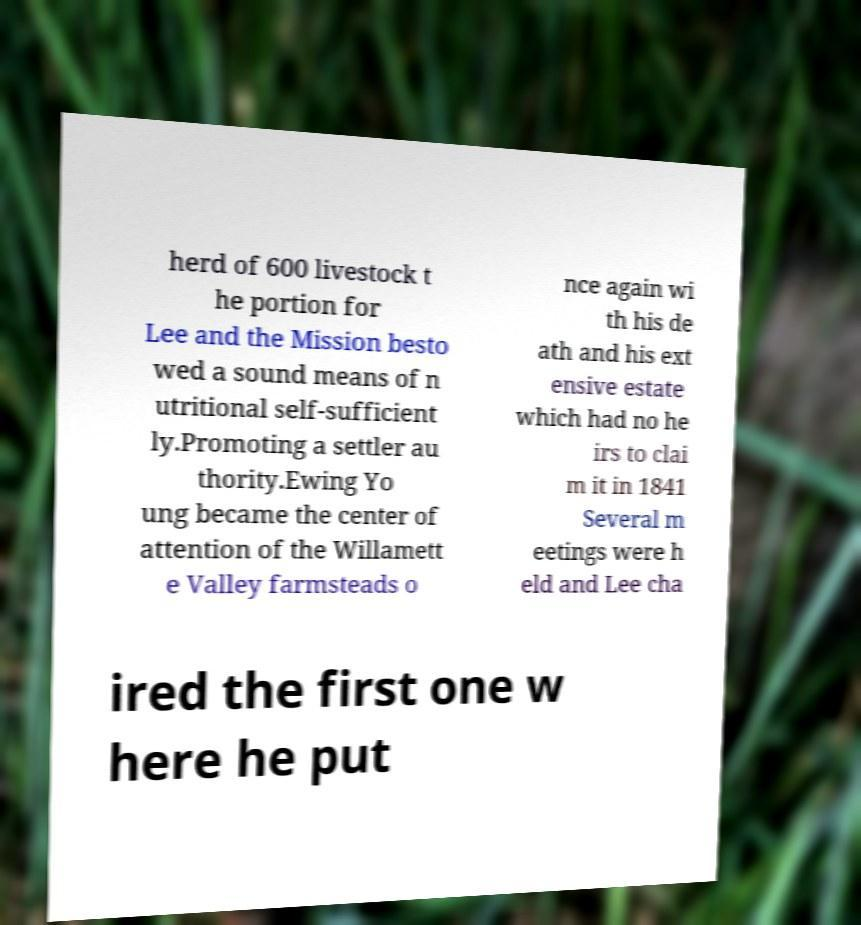Could you assist in decoding the text presented in this image and type it out clearly? herd of 600 livestock t he portion for Lee and the Mission besto wed a sound means of n utritional self-sufficient ly.Promoting a settler au thority.Ewing Yo ung became the center of attention of the Willamett e Valley farmsteads o nce again wi th his de ath and his ext ensive estate which had no he irs to clai m it in 1841 Several m eetings were h eld and Lee cha ired the first one w here he put 